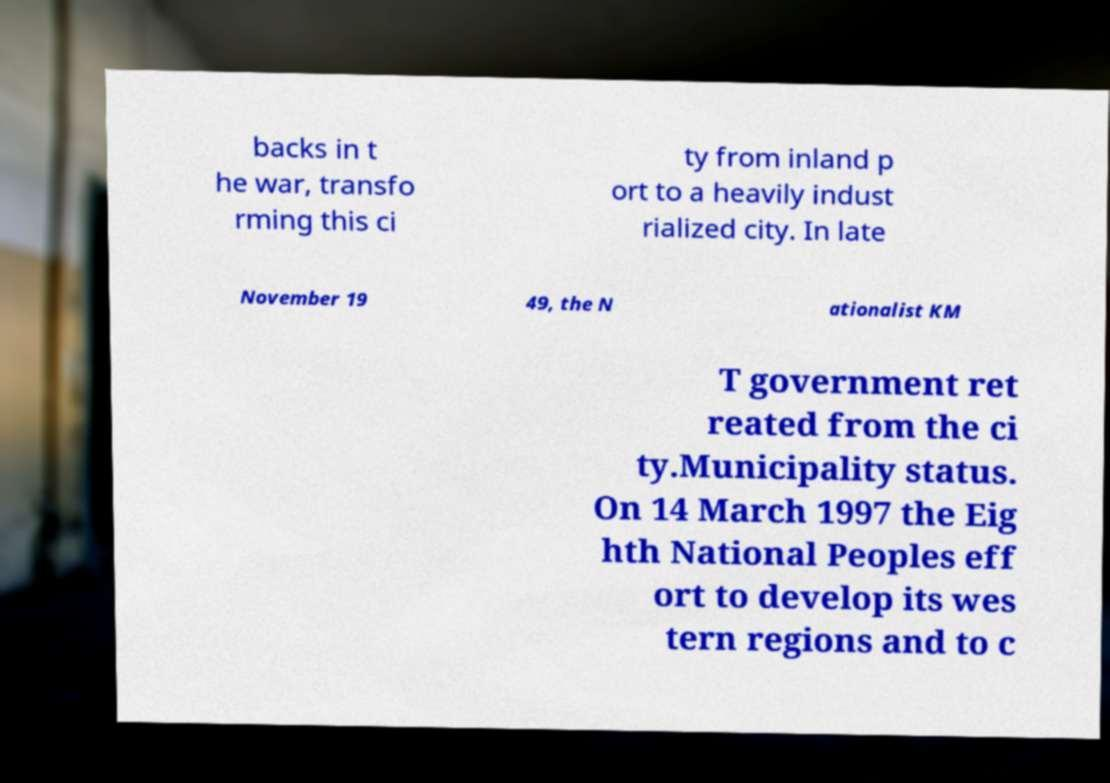For documentation purposes, I need the text within this image transcribed. Could you provide that? backs in t he war, transfo rming this ci ty from inland p ort to a heavily indust rialized city. In late November 19 49, the N ationalist KM T government ret reated from the ci ty.Municipality status. On 14 March 1997 the Eig hth National Peoples eff ort to develop its wes tern regions and to c 